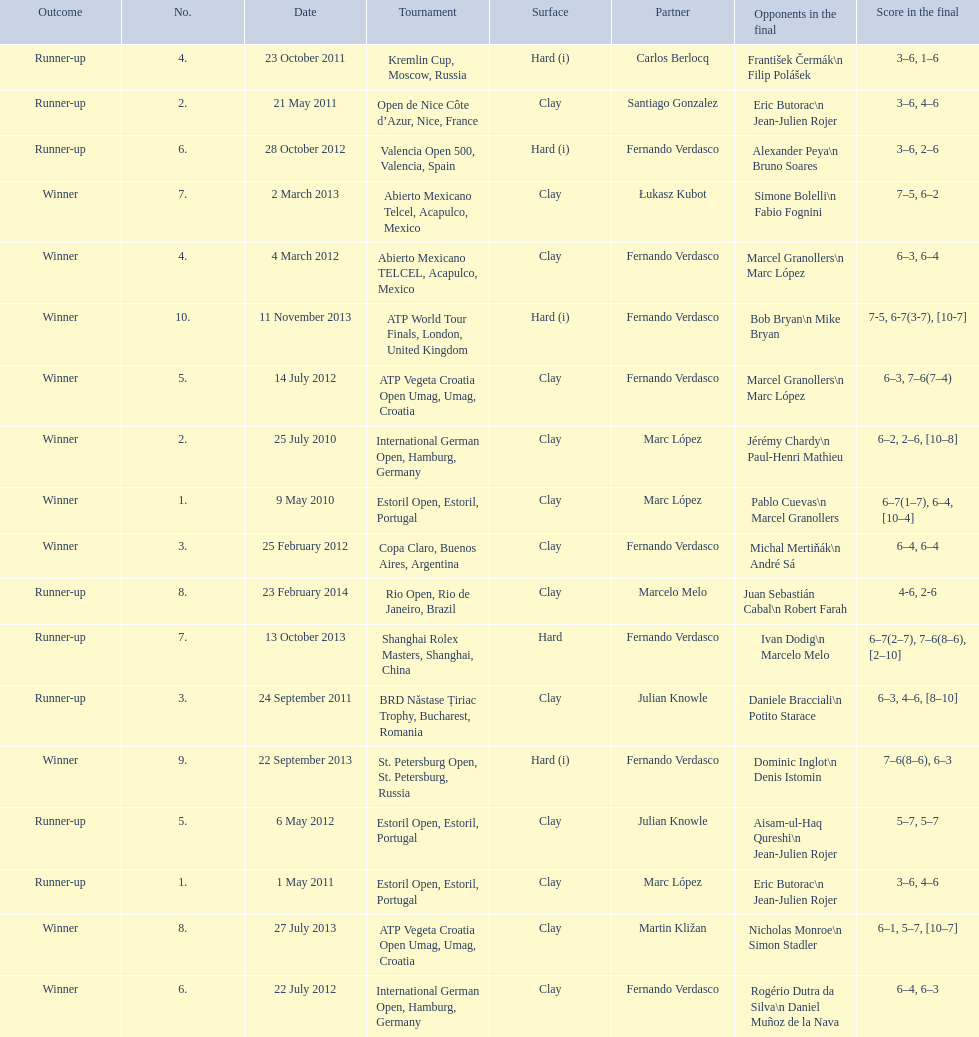What is the number of times a hard surface was used? 5. 